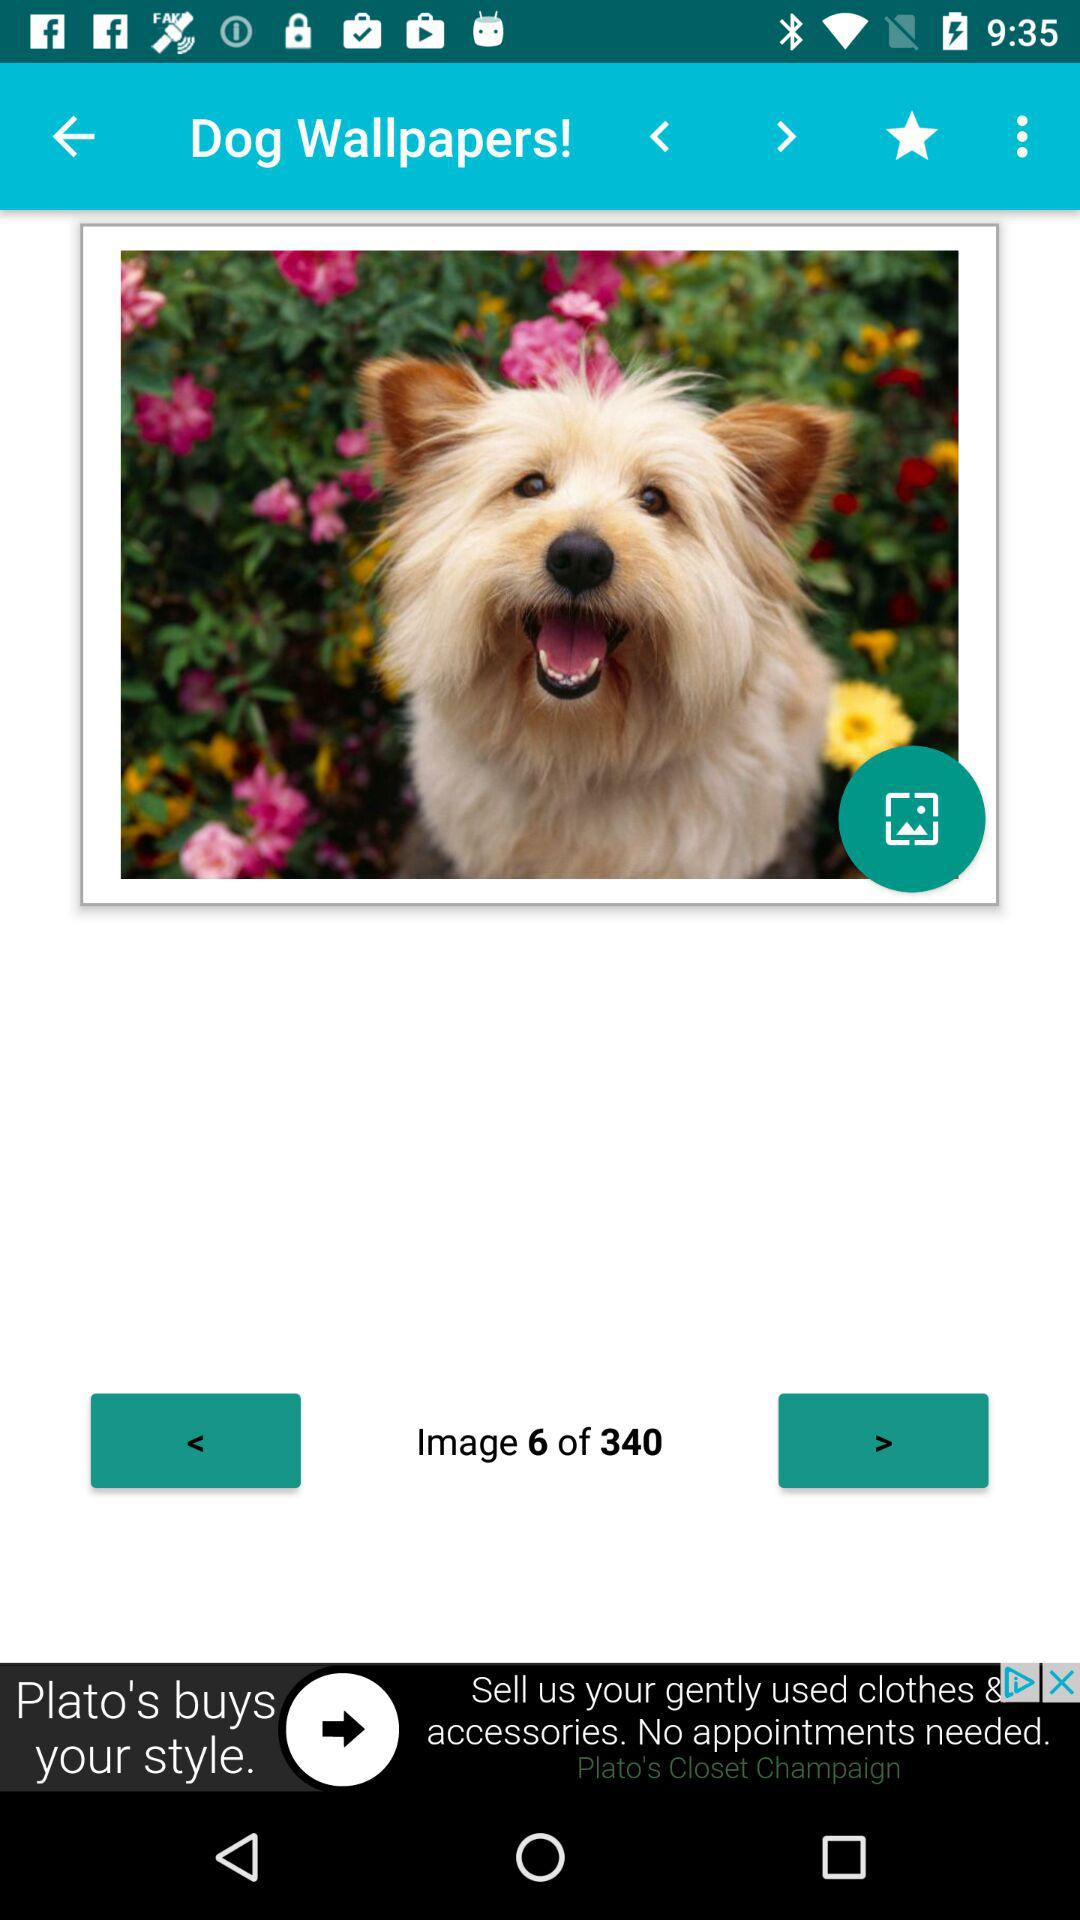What is the application name? The application name is "Dog Wallpapers!". 